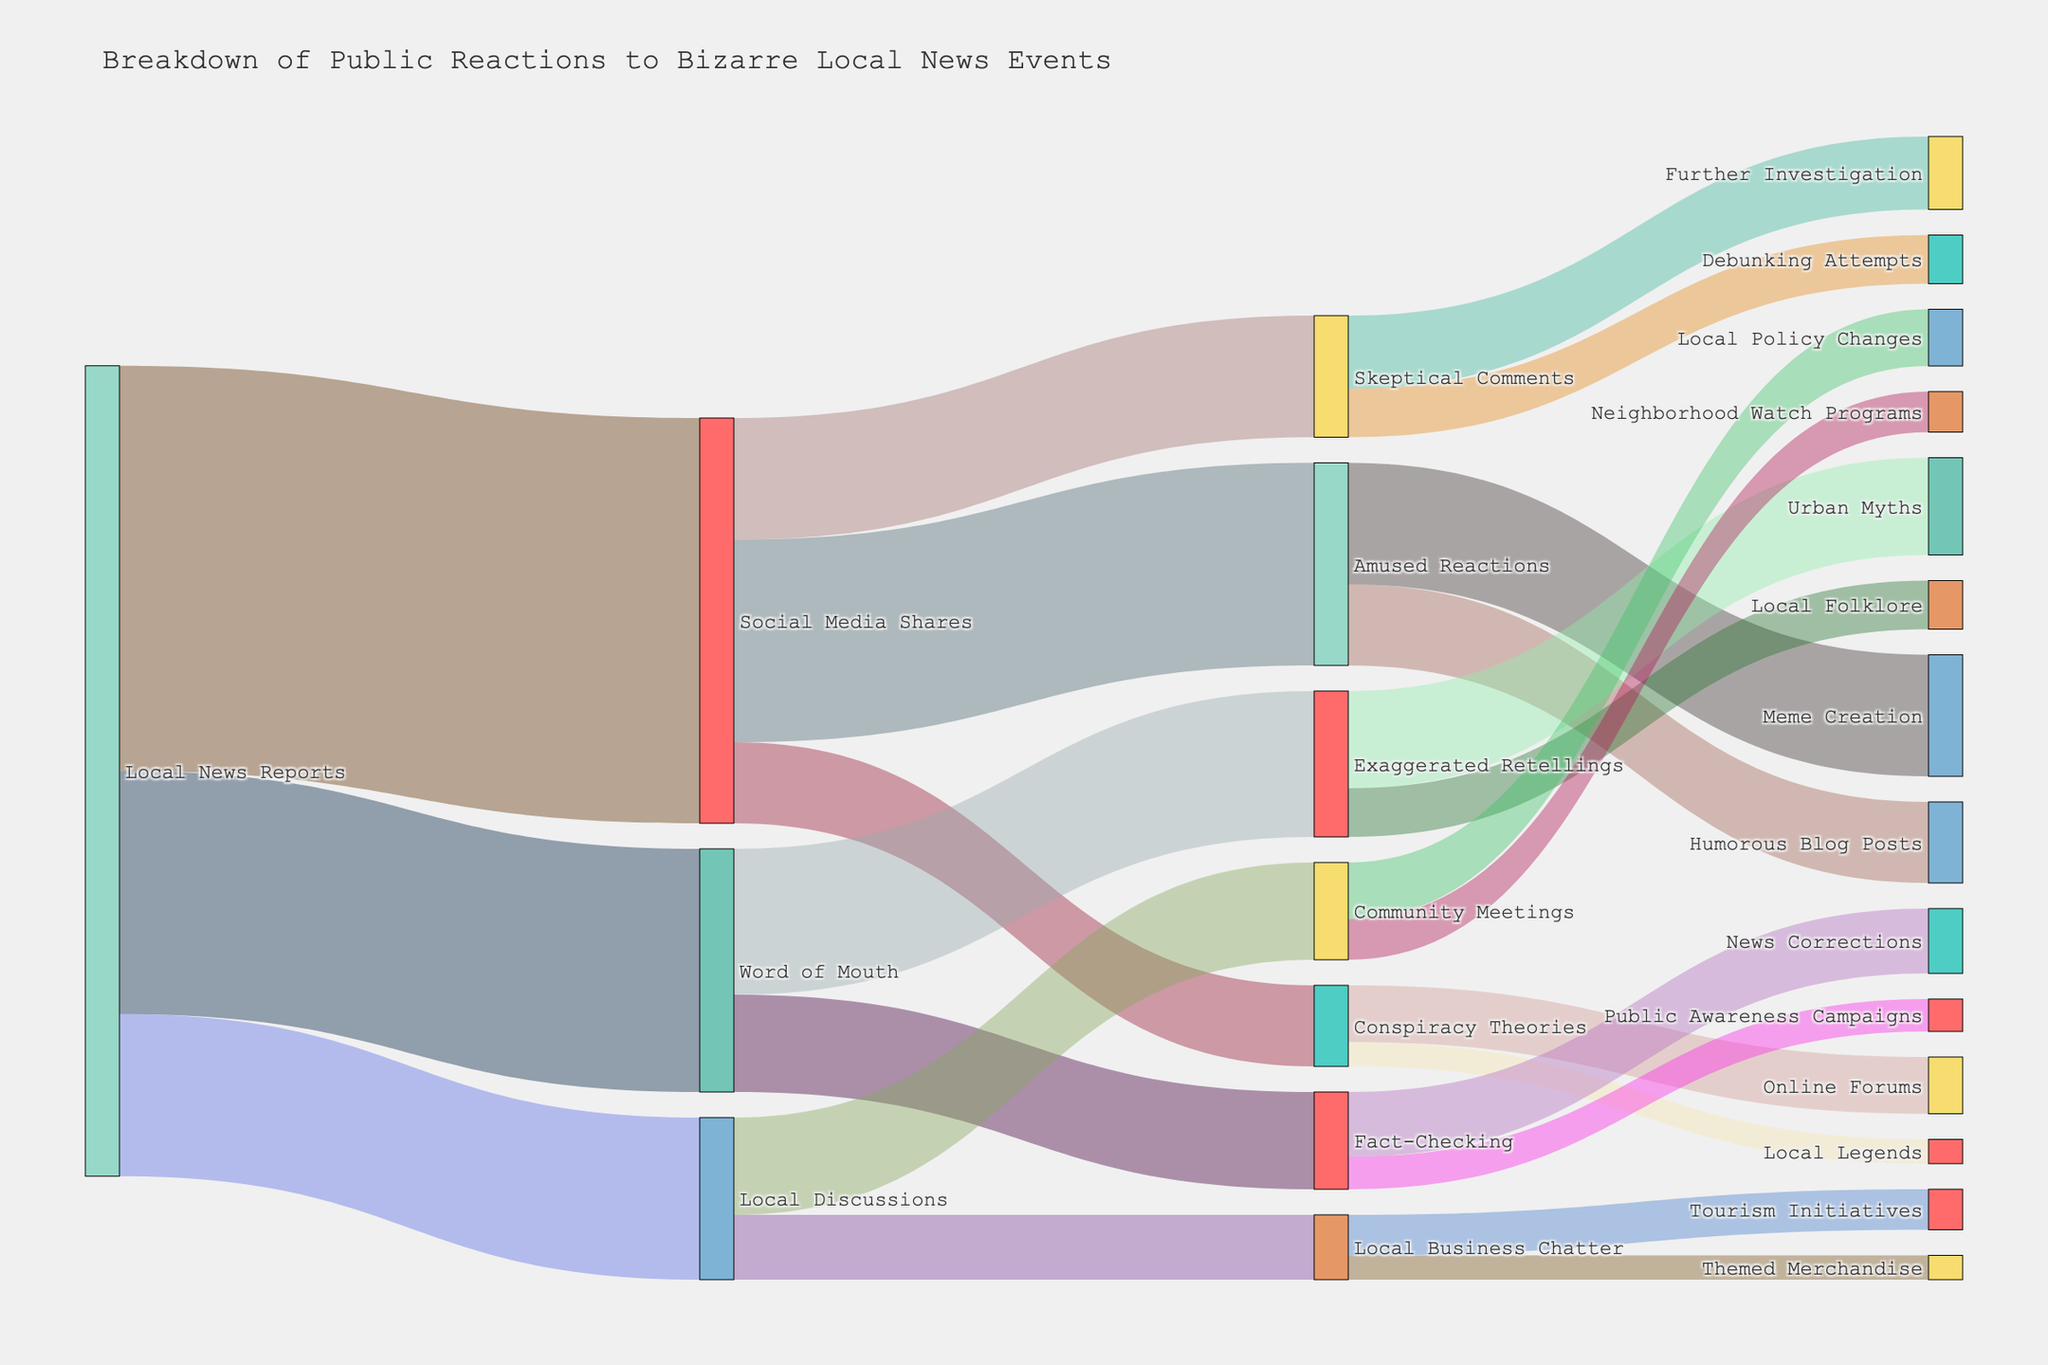What's the title of the Sankey Diagram? The title is written at the top of the Sankey Diagram, providing an overall description of what the figure represents.
Answer: Breakdown of Public Reactions to Bizarre Local News Events Which initial source contributed the most to public reactions? By observing the width of the flows starting from each initial source node, we can identify the source that has the largest outgoing flow value. "Local News Reports" has the largest flow.
Answer: Local News Reports How many public reactions are attributed to "Social Media Shares"? Add the values of all flows entering the "Social Media Shares" node: Amused Reactions (2500) + Skeptical Comments (1500) + Conspiracy Theories (1000).
Answer: 5000 Which target node has the smallest value coming from "Amused Reactions"? Look at the flows originating from "Amused Reactions" and identify the smallest one.
Answer: Humorous Blog Posts What is the combined value of "Exaggerated Retellings" and "Fact-Checking" from "Word of Mouth"? Sum the values of the flows originating from "Word of Mouth" to both "Exaggerated Retellings" and "Fact-Checking". (1800 + 1200) = 3000
Answer: 3000 How does the value of "Debunking Attempts" compare to "Urban Myths"? Compare the flow values for "Debunking Attempts" (600) and "Urban Myths" (1200).
Answer: Debunking Attempts is smaller What percentage of "Amused Reactions" leads to "Meme Creation"? Calculate the fraction of "Meme Creation" out of total "Amused Reactions" and convert to percentage: (1500 / 2500) * 100 = 60%
Answer: 60% How many different sub-reactions originate from "Local Business Chatter"? Count the number of targets connected to "Local Business Chatter". There are 2: Tourism Initiatives and Themed Merchandise.
Answer: 2 What's the total value propagating from "Community Meetings"? Add the values of flows originating from "Community Meetings": Local Policy Changes (700) + Neighborhood Watch Programs (500).
Answer: 1200 